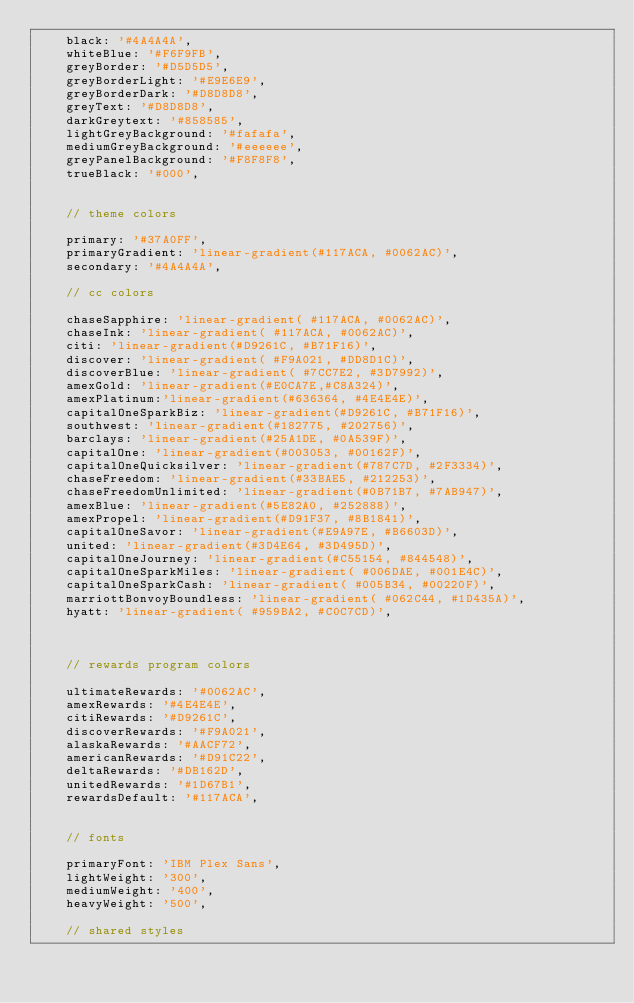<code> <loc_0><loc_0><loc_500><loc_500><_JavaScript_>    black: '#4A4A4A',
    whiteBlue: '#F6F9FB',
    greyBorder: '#D5D5D5',
    greyBorderLight: '#E9E6E9',
    greyBorderDark: '#D8D8D8',
    greyText: '#D8D8D8',
    darkGreytext: '#858585',
    lightGreyBackground: '#fafafa',
    mediumGreyBackground: '#eeeeee',
    greyPanelBackground: '#F8F8F8',
    trueBlack: '#000',

    
    // theme colors
    
    primary: '#37A0FF',
    primaryGradient: 'linear-gradient(#117ACA, #0062AC)',
    secondary: '#4A4A4A',

    // cc colors

    chaseSapphire: 'linear-gradient( #117ACA, #0062AC)',
    chaseInk: 'linear-gradient( #117ACA, #0062AC)',
    citi: 'linear-gradient(#D9261C, #B71F16)',
    discover: 'linear-gradient( #F9A021, #DD8D1C)',
    discoverBlue: 'linear-gradient( #7CC7E2, #3D7992)',
    amexGold: 'linear-gradient(#E0CA7E,#C8A324)',
    amexPlatinum:'linear-gradient(#636364, #4E4E4E)',
    capitalOneSparkBiz: 'linear-gradient(#D9261C, #B71F16)',
    southwest: 'linear-gradient(#182775, #202756)',
    barclays: 'linear-gradient(#25A1DE, #0A539F)',
    capitalOne: 'linear-gradient(#003053, #00162F)',
    capitalOneQuicksilver: 'linear-gradient(#787C7D, #2F3334)',
    chaseFreedom: 'linear-gradient(#33BAE5, #212253)',
    chaseFreedomUnlimited: 'linear-gradient(#0B71B7, #7AB947)',
    amexBlue: 'linear-gradient(#5E82A0, #252888)',
    amexPropel: 'linear-gradient(#D91F37, #8B1841)',
    capitalOneSavor: 'linear-gradient(#E9A97E, #B6603D)',
    united: 'linear-gradient(#3D4E64, #3D495D)', 
    capitalOneJourney: 'linear-gradient(#C55154, #844548)', 
    capitalOneSparkMiles: 'linear-gradient( #006DAE, #001E4C)',
    capitalOneSparkCash: 'linear-gradient( #005B34, #00220F)',
    marriottBonvoyBoundless: 'linear-gradient( #062C44, #1D435A)',
    hyatt: 'linear-gradient( #959BA2, #C0C7CD)',
    


    // rewards program colors

    ultimateRewards: '#0062AC',
    amexRewards: '#4E4E4E',
    citiRewards: '#D9261C',
    discoverRewards: '#F9A021',
    alaskaRewards: '#AACF72',
    americanRewards: '#D91C22',
    deltaRewards: '#DB162D',
    unitedRewards: '#1D67B1',
    rewardsDefault: '#117ACA',


    // fonts

    primaryFont: 'IBM Plex Sans',
    lightWeight: '300',
    mediumWeight: '400',
    heavyWeight: '500',

    // shared styles
</code> 